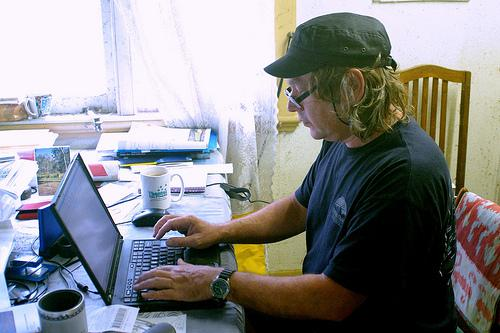Question: where is the picture taken?
Choices:
A. In a bank.
B. In a house.
C. In a school.
D. In a store.
Answer with the letter. Answer: B Question: what is the color of the laptop?
Choices:
A. Blue.
B. Light gray.
C. Bright green.
D. Black.
Answer with the letter. Answer: D Question: how many laptops are there?
Choices:
A. Two.
B. Three.
C. Four.
D. One.
Answer with the letter. Answer: D 